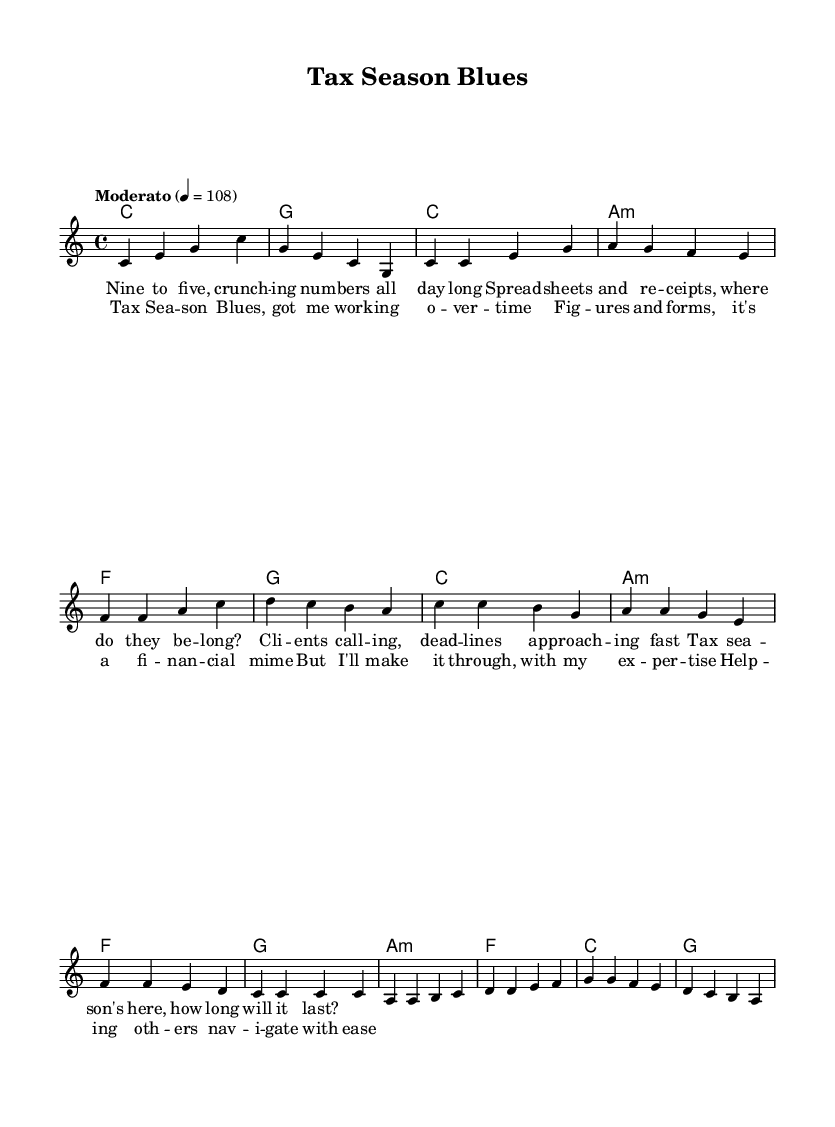What is the key signature of this music? The key signature is C major, which has no sharps or flats, as indicated by the clear absence of any sharp or flat symbols at the beginning of the staff.
Answer: C major What is the time signature of this piece? The time signature is 4/4, marked at the beginning of the sheet music. This means there are four beats per measure, and each quarter note gets one beat.
Answer: 4/4 What is the tempo marking for this piece? The tempo marking is "Moderato" with a metronome marking of 108 beats per minute, shown in the tempo text at the start of the piece.
Answer: Moderato 4 = 108 How many measures are in the verse? The verse has eight measures, as can be counted from the melody section that corresponds to the described lyrics. Each group of notes represents one measure.
Answer: 8 measures What is the main theme of the lyrics? The main theme is about the challenges of tax season and the stress of filing taxes, encapsulating the experience of working in a financial context. This can be derived from the lyrics describing the work tasks and client interactions.
Answer: Tax season What chord is used during the chorus? The chorus primarily uses the chords C major, A minor, F major, and G major, as indicated in the harmonies section throughout the chorus lyrics.
Answer: C major, A minor, F major, G major How does the bridge contrast with the verse? The bridge introduces a different progression (A minor, F, C, G) compared to the verse (C, A minor, F, G). This contrast can provide variety and highlights a shift in the musical narrative from the verse to the bridge.
Answer: Different chord progression 